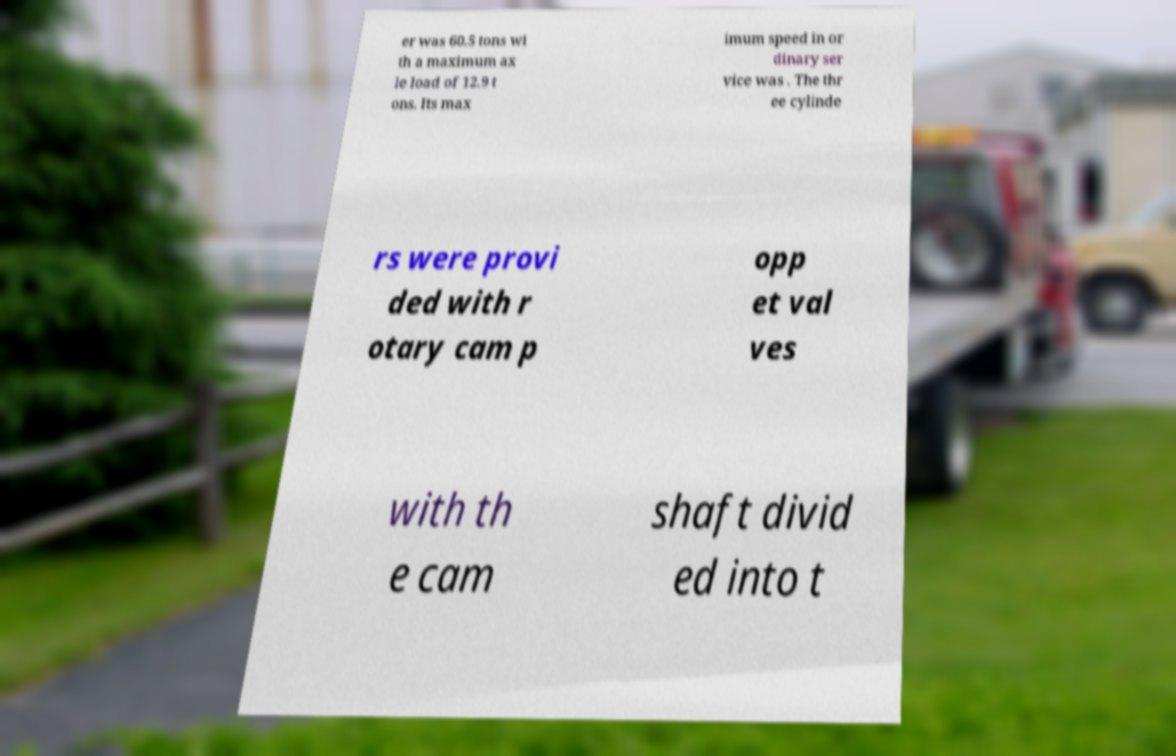What messages or text are displayed in this image? I need them in a readable, typed format. er was 60.5 tons wi th a maximum ax le load of 12.9 t ons. Its max imum speed in or dinary ser vice was . The thr ee cylinde rs were provi ded with r otary cam p opp et val ves with th e cam shaft divid ed into t 